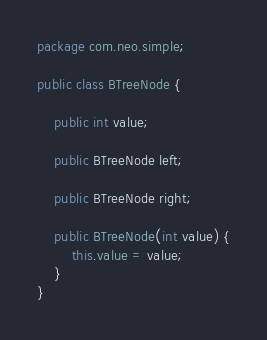<code> <loc_0><loc_0><loc_500><loc_500><_Java_>package com.neo.simple;

public class BTreeNode {

    public int value;

    public BTreeNode left;

    public BTreeNode right;

    public BTreeNode(int value) {
        this.value = value;
    }
}
</code> 